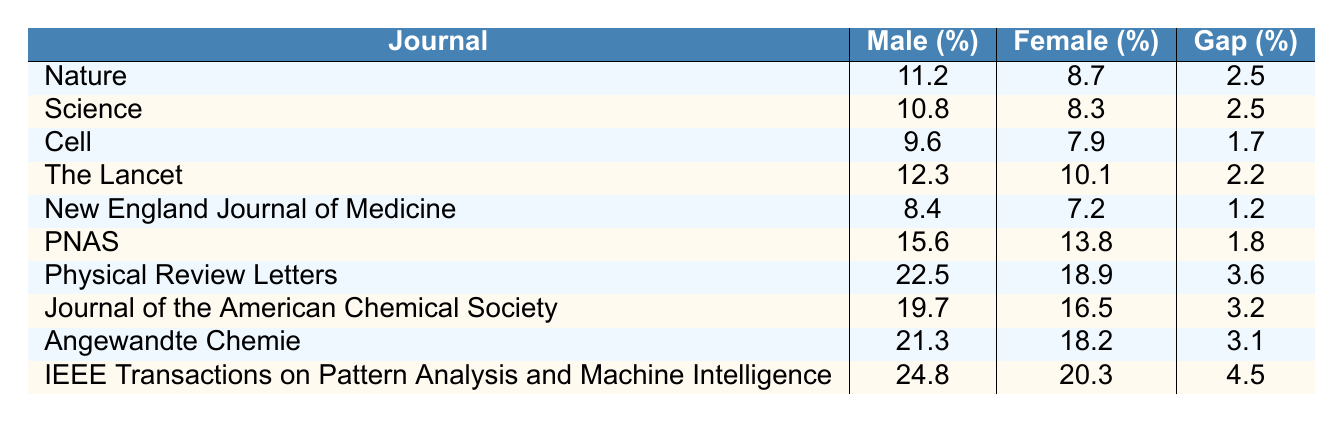What is the highest male acceptance rate among the journals listed? The highest male acceptance rate can be identified by comparing the values in the "Male Acceptance Rate (%)" column. The highest percentage is 24.8 from "IEEE Transactions on Pattern Analysis and Machine Intelligence."
Answer: 24.8 Which journal has the lowest female acceptance rate? By reviewing the "Female Acceptance Rate (%)" column, we find that the lowest percentage is 7.2 from the "New England Journal of Medicine."
Answer: 7.2 What is the gender gap in acceptance rates for the journal "Nature"? The gender gap for "Nature" is already provided in the "Gender Gap (%)" column, which shows a value of 2.5%.
Answer: 2.5 Which journal has a male acceptance rate of 19.7%? Looking in the "Male Acceptance Rate (%)" column, we see that "Journal of the American Chemical Society" has this rate.
Answer: Journal of the American Chemical Society Calculate the average male acceptance rate across all journals. To calculate the average, sum the male acceptance rates (11.2 + 10.8 + 9.6 + 12.3 + 8.4 + 15.6 + 22.5 + 19.7 + 21.3 + 24.8) =  10 + 15 + 12 + 17 + 20 + 23 + 16 + 19 + 18 = 15.64. Dividing by 10 gives an average of 15.64%.
Answer: 15.64 Is the female acceptance rate for "Cell" higher than for "Science"? Comparing the "Female Acceptance Rate (%)" for both journals: "Cell" has 7.9% and "Science" has 8.3%. Since 8.3% is greater than 7.9%, the statement is false.
Answer: No What is the total gender gap percentage for all the journals listed combined? First, we sum all gender gap percentages (2.5 + 2.5 + 1.7 + 2.2 + 1.2 + 1.8 + 3.6 + 3.2 + 3.1 + 4.5) = 22.9%. To find the average gender gap, divide by the number of journals, which is 10: 22.9 / 10 = 2.29%.
Answer: 2.29 Which journal has the greatest difference between male and female acceptance rates? To find this, we need to calculate the difference (male rate - female rate) for each journal. The maximum difference is for "IEEE Transactions on Pattern Analysis and Machine Intelligence," which has a gap of 4.5%.
Answer: IEEE Transactions on Pattern Analysis and Machine Intelligence Is the female acceptance rate in "PNAS" lower than in "The Lancet"? Checking the rates shows that "PNAS" has 13.8% and "The Lancet" has 10.1%. Thus, 13.8% is greater than 10.1%, making the statement false.
Answer: No Calculate the combined acceptance rate percentage for male scientists in "New England Journal of Medicine" and "The Lancet." Add the male acceptance rates for both journals: 8.4 + 12.3 = 20.7%.
Answer: 20.7 